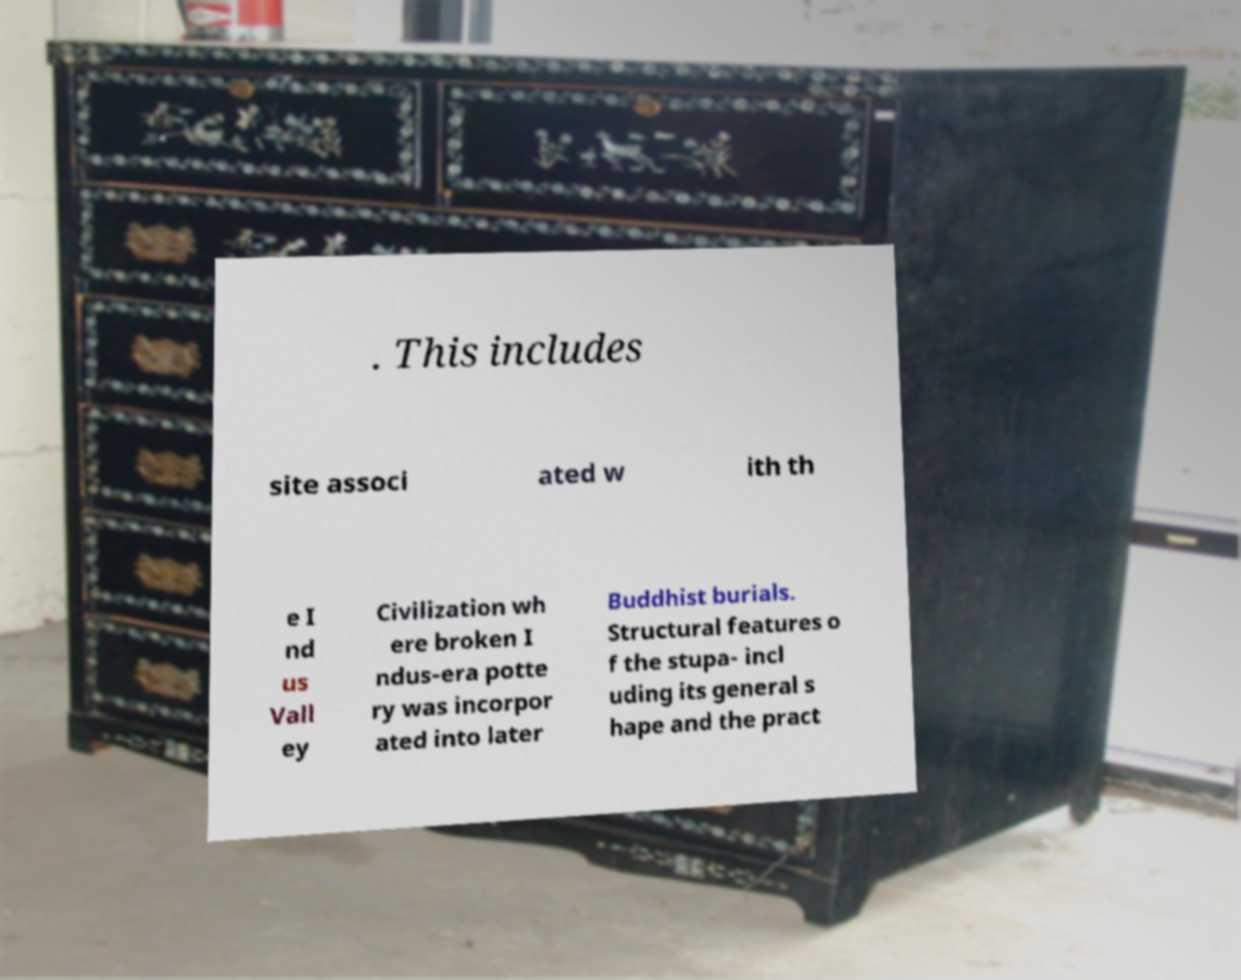Could you extract and type out the text from this image? . This includes site associ ated w ith th e I nd us Vall ey Civilization wh ere broken I ndus-era potte ry was incorpor ated into later Buddhist burials. Structural features o f the stupa- incl uding its general s hape and the pract 